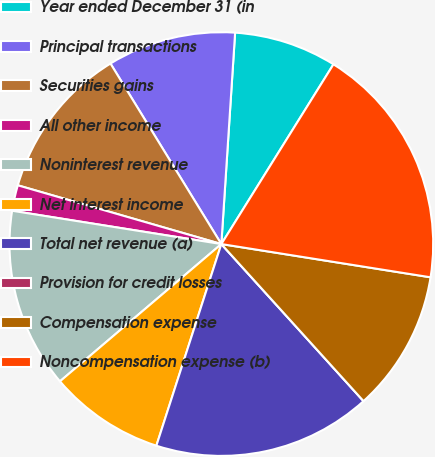<chart> <loc_0><loc_0><loc_500><loc_500><pie_chart><fcel>Year ended December 31 (in<fcel>Principal transactions<fcel>Securities gains<fcel>All other income<fcel>Noninterest revenue<fcel>Net interest income<fcel>Total net revenue (a)<fcel>Provision for credit losses<fcel>Compensation expense<fcel>Noncompensation expense (b)<nl><fcel>7.84%<fcel>9.8%<fcel>11.76%<fcel>1.96%<fcel>13.73%<fcel>8.82%<fcel>16.67%<fcel>0.0%<fcel>10.78%<fcel>18.63%<nl></chart> 